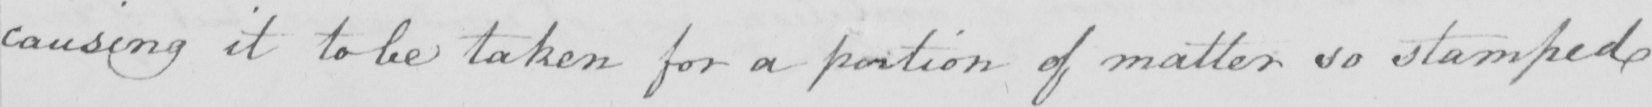Transcribe the text shown in this historical manuscript line. causing it to be taken for a portion of matter so stamped 